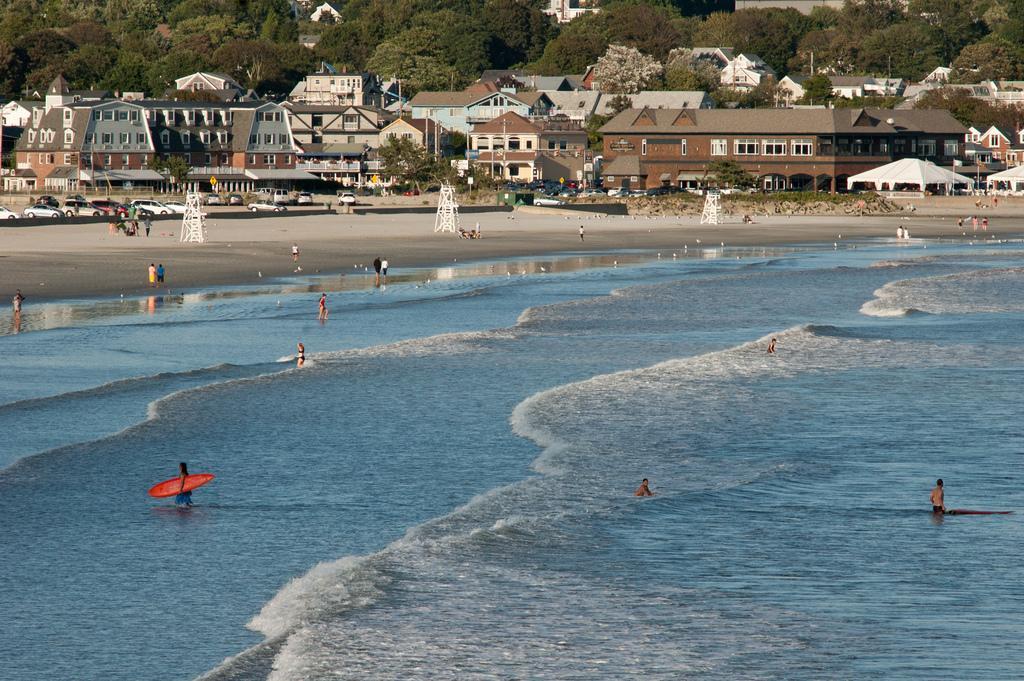How would you summarize this image in a sentence or two? In this image I can see water, people, sea shore, vehicles, buildings, trees and in the sea shore there are some white objects. 